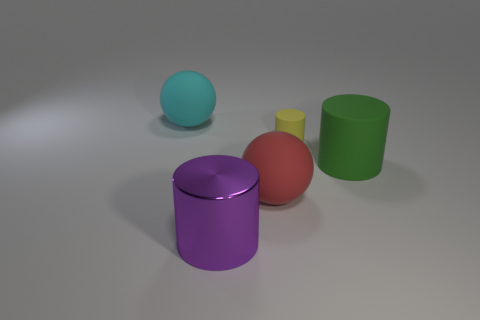Add 1 tiny rubber cylinders. How many objects exist? 6 Subtract all balls. How many objects are left? 3 Add 1 large red spheres. How many large red spheres are left? 2 Add 1 large cyan rubber spheres. How many large cyan rubber spheres exist? 2 Subtract 0 yellow cubes. How many objects are left? 5 Subtract all large green matte objects. Subtract all large purple cylinders. How many objects are left? 3 